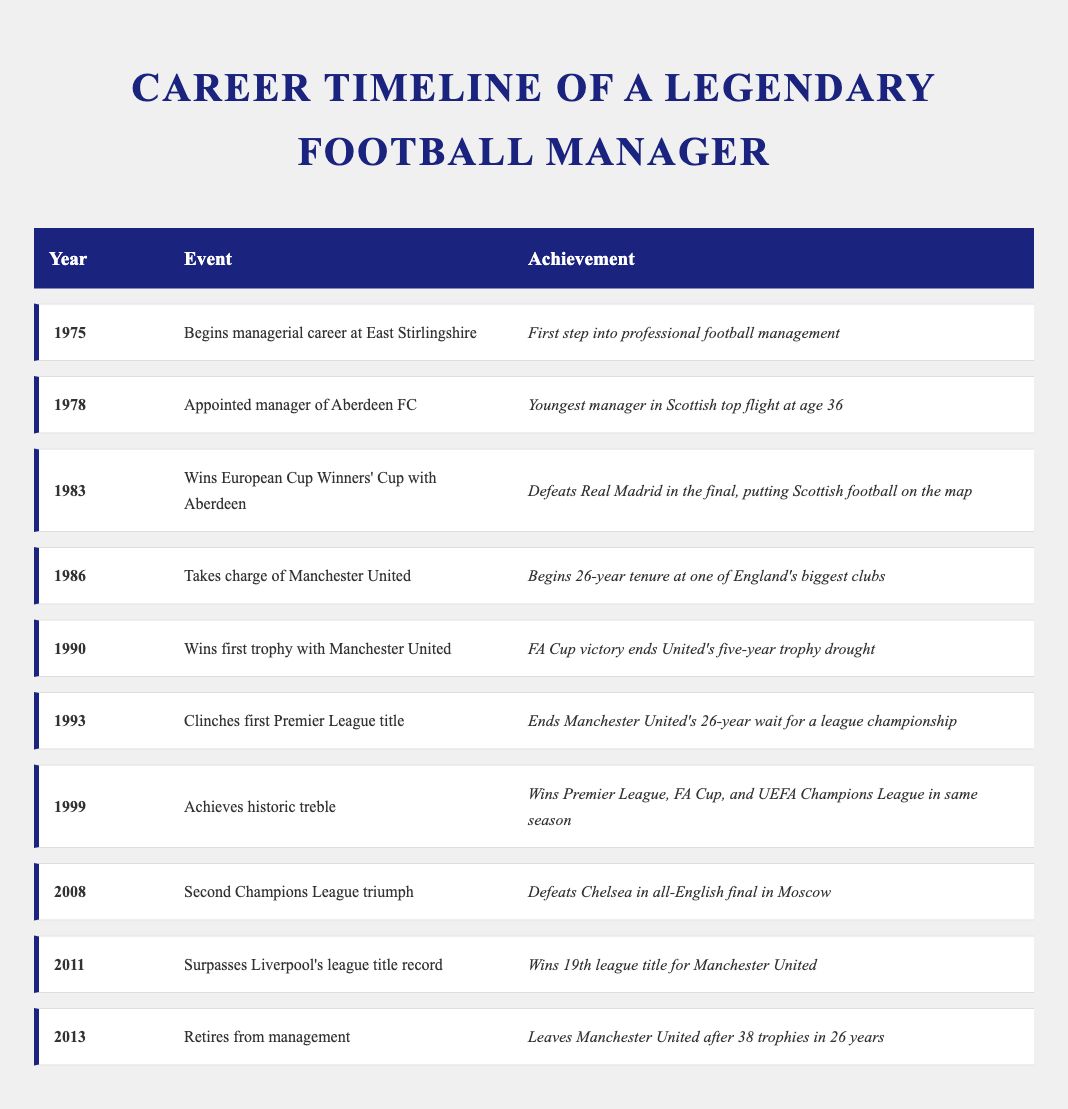What year did the legendary manager achieve his first Premier League title? The table shows that the manager clinched his first Premier League title in 1993.
Answer: 1993 How many years did the manager spend at Manchester United before retiring? The manager began his tenure at Manchester United in 1986 and retired in 2013. The difference between these years is 2013 - 1986 = 27 years.
Answer: 27 years Is it true that the manager won a trophy in his first year at Manchester United? The table indicates that the first trophy won by the manager at Manchester United was in 1990, which is four years after he took charge in 1986. Thus, it is not true.
Answer: No What major trophies did the manager achieve in the year 1999? According to the table, in 1999, the manager achieved a historic treble, winning the Premier League, FA Cup, and UEFA Champions League in the same season.
Answer: Premier League, FA Cup, UEFA Champions League How many total trophies did the manager win during his career? The table states that he left Manchester United with 38 trophies after 26 years. Therefore, the total number of trophies he won during his career is 38.
Answer: 38 trophies In which year did the manager first achieve a European trophy? The table indicates that the manager first won a European trophy with Aberdeen FC in 1983.
Answer: 1983 Was the manager's tenure at Manchester United longer than his entire career before that? The manager had a managerial career that began in 1975 and lasted until 2013, which includes 38 years. His time at Manchester United from 1986 to 2013 was 27 years, so yes, his entire career was longer.
Answer: Yes What event marked the manager's departure from Manchester United? The table explicitly states that the manager retired from management in 2013, marking his departure from Manchester United after 38 trophies in 26 years.
Answer: Retirement in 2013 